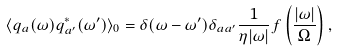<formula> <loc_0><loc_0><loc_500><loc_500>\langle q _ { a } ( \omega ) q _ { a ^ { \prime } } ^ { * } ( \omega ^ { \prime } ) \rangle _ { 0 } = \delta ( \omega - \omega ^ { \prime } ) \delta _ { a a ^ { \prime } } \frac { 1 } { \eta | \omega | } f \left ( \frac { | \omega | } { \Omega } \right ) ,</formula> 